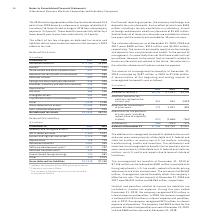According to International Business Machines's financial document, How much amount did the unrecognized tax benefits increased in 2019? According to the financial document, $387 million. The relevant text states: "zed tax benefits at December 31, 2019 increased by $387 million in 2019 to $7,146 million. A reconciliation of the beginning and ending amount of unrecognized tax b..." Also, What attributed to settlements and reductions to unrecognized tax benefits? The settlements and reductions to unrecognized tax benefits for tax positions of prior years were primarily attributable to U.S. federal and state tax matters, non-U.S. audits and impacts due to lapse of statute of limitations.. The document states: "ncluding transfer pricing, credits and incentives. The settlements and reductions to unrecognized tax benefits for tax positions of prior years were p..." Also, In December 2019, how much reduction was associated to timing adjustments, U.S. tax credits, potential transfer pricing adjustments and state income taxes. According to the financial document, $584 million. The relevant text states: "ember 31, 2019 of $7,146 million can be reduced by $584 million associated with timing adjustments, U.S. tax credits, potential transfer pricing adjustments and sta..." Also, can you calculate: What is the average of Balance at January 1? To answer this question, I need to perform calculations using the financial data. The calculation is: (6,759+7,031+3,740) / 3, which equals 5843.33 (in millions). This is based on the information: "Balance at January 1 $6,759 $ 7,031 $3,740 Balance at January 1 $6,759 $ 7,031 $3,740 Balance at January 1 $6,759 $ 7,031 $3,740..." The key data points involved are: 3,740, 6,759, 7,031. Also, can you calculate: What is the average of Balance at December 31? To answer this question, I need to perform calculations using the financial data. The calculation is: (7,146+6,759+7,031) / 3, which equals 6978.67 (in millions). This is based on the information: "Balance at January 1 $6,759 $ 7,031 $3,740 Balance at December 31 $7,146 $ 6,759 $7,031 Balance at January 1 $6,759 $ 7,031 $3,740..." The key data points involved are: 6,759, 7,031, 7,146. Also, can you calculate: What is the average of Settlements for the period 2018-19? To answer this question, I need to perform calculations using the financial data. The calculation is: (-286+(-181)) / 2, which equals -233.5 (in millions). This is based on the information: "Settlements (286) (181) (174) Settlements (286) (181) (174) Settlements (286) (181) (174)..." The key data points involved are: 181, 286. 